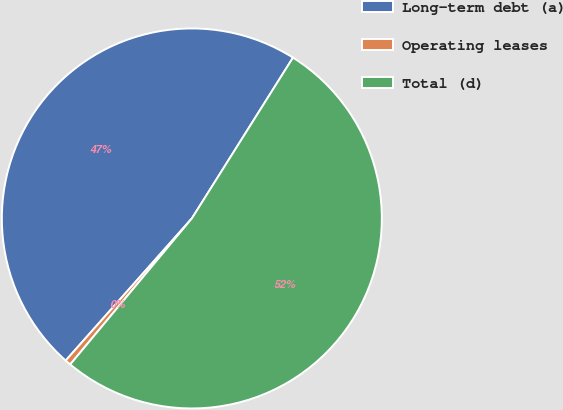Convert chart to OTSL. <chart><loc_0><loc_0><loc_500><loc_500><pie_chart><fcel>Long-term debt (a)<fcel>Operating leases<fcel>Total (d)<nl><fcel>47.38%<fcel>0.5%<fcel>52.12%<nl></chart> 